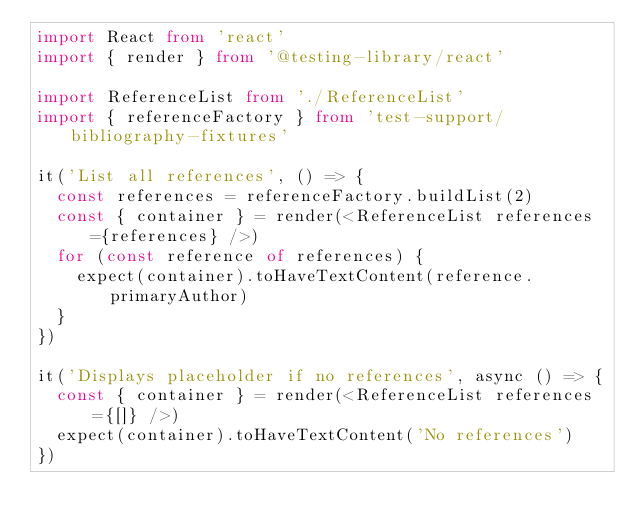<code> <loc_0><loc_0><loc_500><loc_500><_TypeScript_>import React from 'react'
import { render } from '@testing-library/react'

import ReferenceList from './ReferenceList'
import { referenceFactory } from 'test-support/bibliography-fixtures'

it('List all references', () => {
  const references = referenceFactory.buildList(2)
  const { container } = render(<ReferenceList references={references} />)
  for (const reference of references) {
    expect(container).toHaveTextContent(reference.primaryAuthor)
  }
})

it('Displays placeholder if no references', async () => {
  const { container } = render(<ReferenceList references={[]} />)
  expect(container).toHaveTextContent('No references')
})
</code> 